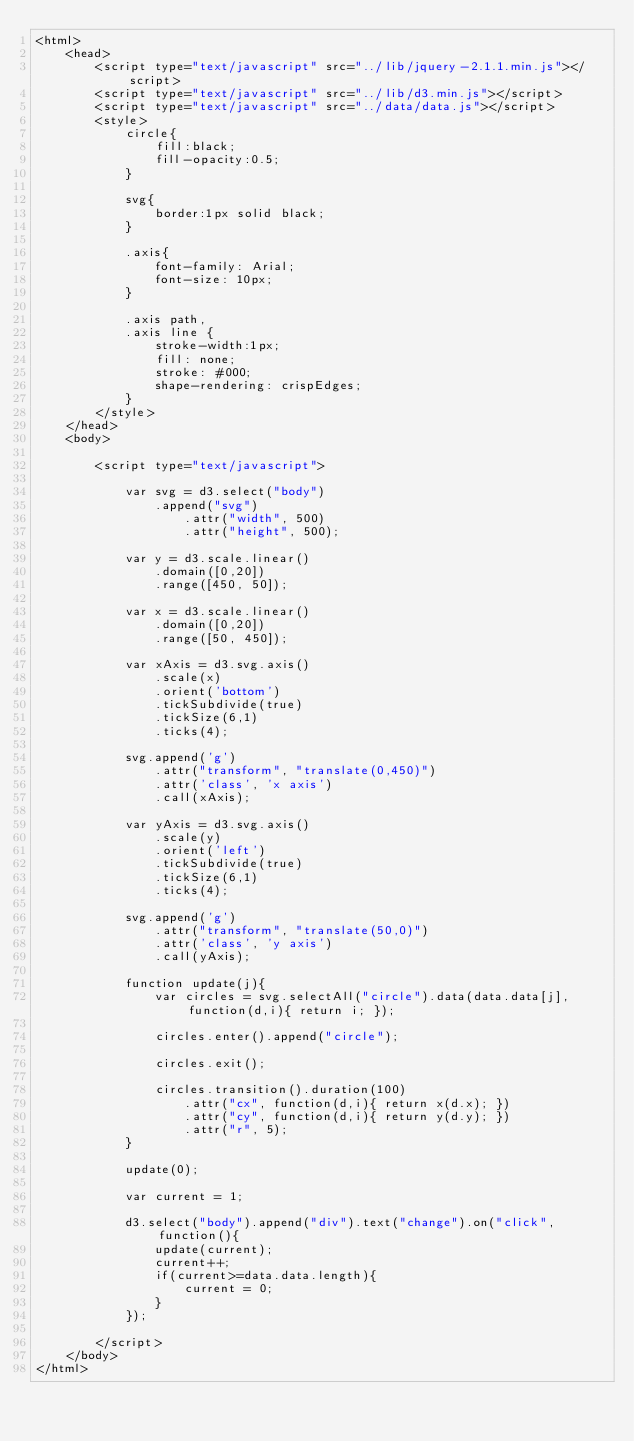<code> <loc_0><loc_0><loc_500><loc_500><_HTML_><html>
	<head>
		<script type="text/javascript" src="../lib/jquery-2.1.1.min.js"></script>
		<script type="text/javascript" src="../lib/d3.min.js"></script>
		<script type="text/javascript" src="../data/data.js"></script>
		<style>
			circle{
				fill:black;
				fill-opacity:0.5;
			}

			svg{
				border:1px solid black;
			}

			.axis{
				font-family: Arial;
				font-size: 10px;
			}

			.axis path,
			.axis line {
				stroke-width:1px;	
				fill: none;
				stroke: #000;
				shape-rendering: crispEdges;
			}
		</style>
	</head>
	<body>

		<script type="text/javascript">

			var svg = d3.select("body")
				.append("svg")
					.attr("width", 500)
					.attr("height", 500);

			var y = d3.scale.linear()
				.domain([0,20])
				.range([450, 50]);

			var x = d3.scale.linear()
				.domain([0,20])
				.range([50, 450]);

			var xAxis = d3.svg.axis()
				.scale(x)
				.orient('bottom')
				.tickSubdivide(true)
				.tickSize(6,1)
				.ticks(4);

			svg.append('g')
				.attr("transform", "translate(0,450)")
				.attr('class', 'x axis')
				.call(xAxis);

			var yAxis = d3.svg.axis()
				.scale(y)
				.orient('left')
				.tickSubdivide(true)
				.tickSize(6,1)
				.ticks(4);

			svg.append('g')
				.attr("transform", "translate(50,0)")
				.attr('class', 'y axis')
				.call(yAxis);

			function update(j){
				var circles = svg.selectAll("circle").data(data.data[j], function(d,i){ return i; });

				circles.enter().append("circle");

				circles.exit();

				circles.transition().duration(100)
					.attr("cx", function(d,i){ return x(d.x); })
					.attr("cy", function(d,i){ return y(d.y); })
					.attr("r", 5);
			}

			update(0);

			var current = 1;

			d3.select("body").append("div").text("change").on("click", function(){
				update(current);
				current++;
				if(current>=data.data.length){
					current = 0;
				}
			});

		</script>
	</body>
</html></code> 